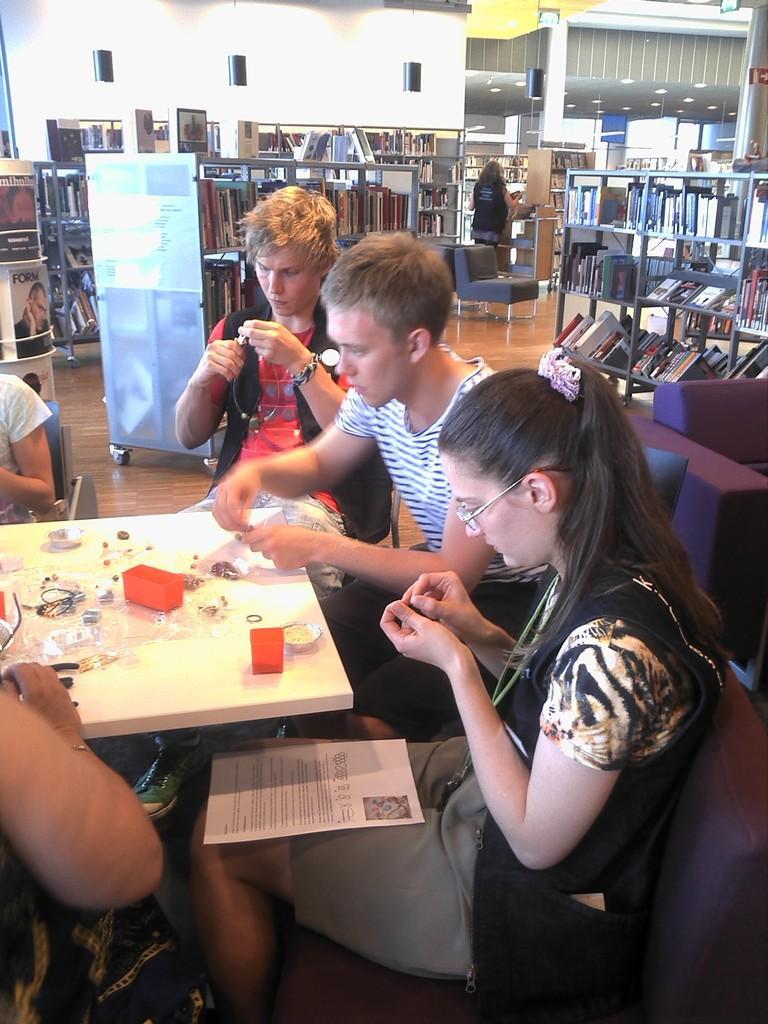Please provide a concise description of this image. There are few people here sitting on the chair at the table. On the table we can see boxes. In the background there is a wall,books in a bookshelf and a light. 